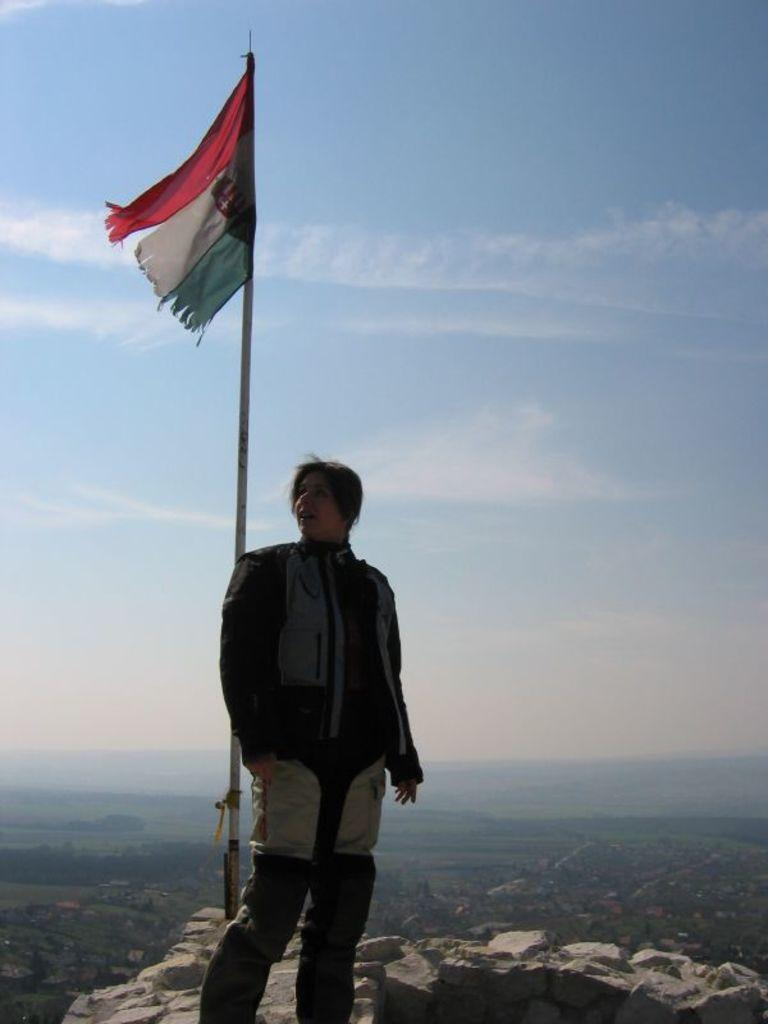Who is the main subject in the image? There is a woman standing in the front of the image. What can be seen on the left side of the image? There is a flag on the left side of the image. What type of ground surface is visible at the bottom of the image? There are stones visible at the bottom of the image. What is visible at the top of the image? The sky is visible at the top of the image. Who is the owner of the fruit depicted in the image? There is no fruit present in the image, so there is no owner to be identified. 